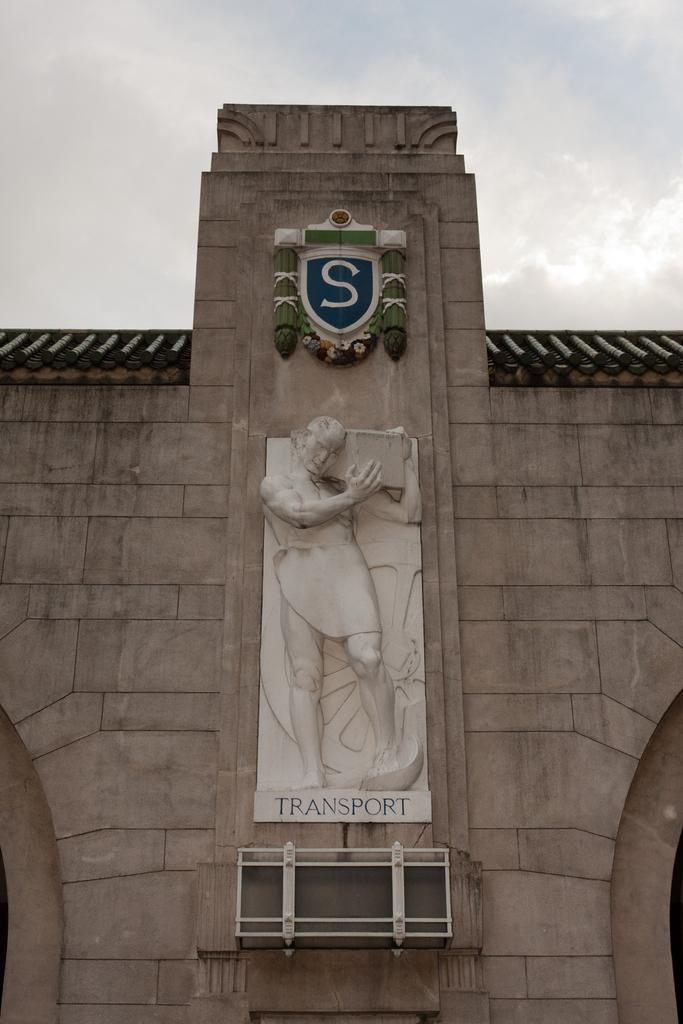<image>
Create a compact narrative representing the image presented. At the top of the statue is the letter S and underneath it is the word transport. 